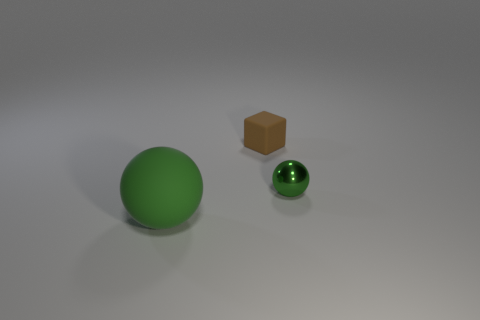Is there anything else that is the same material as the small green ball?
Make the answer very short. No. Is there any other thing that has the same size as the green matte sphere?
Offer a very short reply. No. How big is the metallic object?
Ensure brevity in your answer.  Small. What color is the thing that is both on the left side of the metallic thing and in front of the cube?
Give a very brief answer. Green. Does the green shiny ball have the same size as the ball left of the small brown object?
Your answer should be compact. No. Is there any other thing that is the same shape as the tiny matte object?
Offer a terse response. No. The small thing that is the same shape as the large thing is what color?
Ensure brevity in your answer.  Green. Is the size of the green metallic thing the same as the brown block?
Your answer should be very brief. Yes. How many other objects are there of the same size as the shiny thing?
Give a very brief answer. 1. What number of things are either things that are in front of the small block or things that are behind the big green matte thing?
Your response must be concise. 3. 